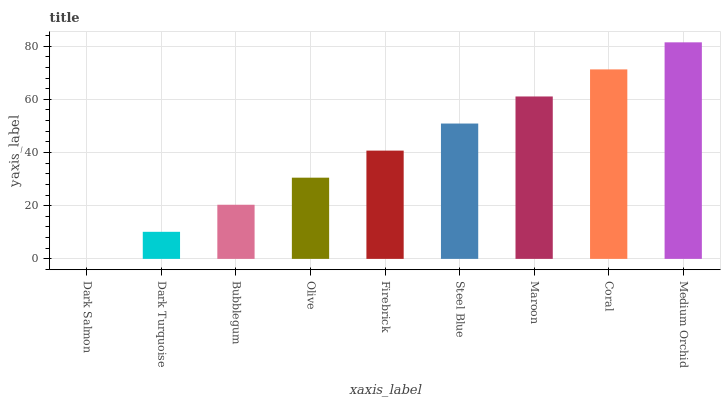Is Dark Salmon the minimum?
Answer yes or no. Yes. Is Medium Orchid the maximum?
Answer yes or no. Yes. Is Dark Turquoise the minimum?
Answer yes or no. No. Is Dark Turquoise the maximum?
Answer yes or no. No. Is Dark Turquoise greater than Dark Salmon?
Answer yes or no. Yes. Is Dark Salmon less than Dark Turquoise?
Answer yes or no. Yes. Is Dark Salmon greater than Dark Turquoise?
Answer yes or no. No. Is Dark Turquoise less than Dark Salmon?
Answer yes or no. No. Is Firebrick the high median?
Answer yes or no. Yes. Is Firebrick the low median?
Answer yes or no. Yes. Is Steel Blue the high median?
Answer yes or no. No. Is Bubblegum the low median?
Answer yes or no. No. 